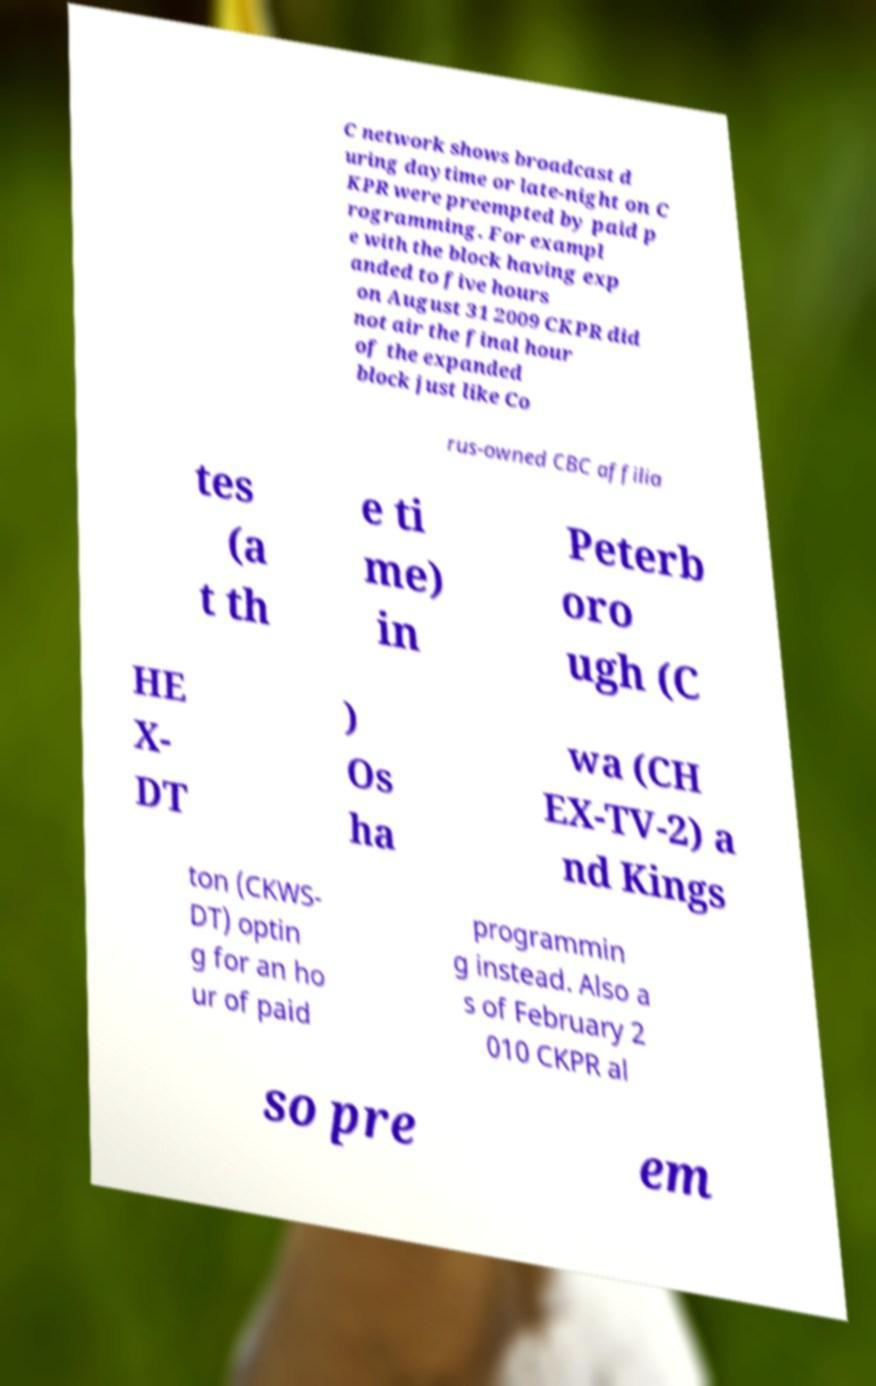Please identify and transcribe the text found in this image. C network shows broadcast d uring daytime or late-night on C KPR were preempted by paid p rogramming. For exampl e with the block having exp anded to five hours on August 31 2009 CKPR did not air the final hour of the expanded block just like Co rus-owned CBC affilia tes (a t th e ti me) in Peterb oro ugh (C HE X- DT ) Os ha wa (CH EX-TV-2) a nd Kings ton (CKWS- DT) optin g for an ho ur of paid programmin g instead. Also a s of February 2 010 CKPR al so pre em 